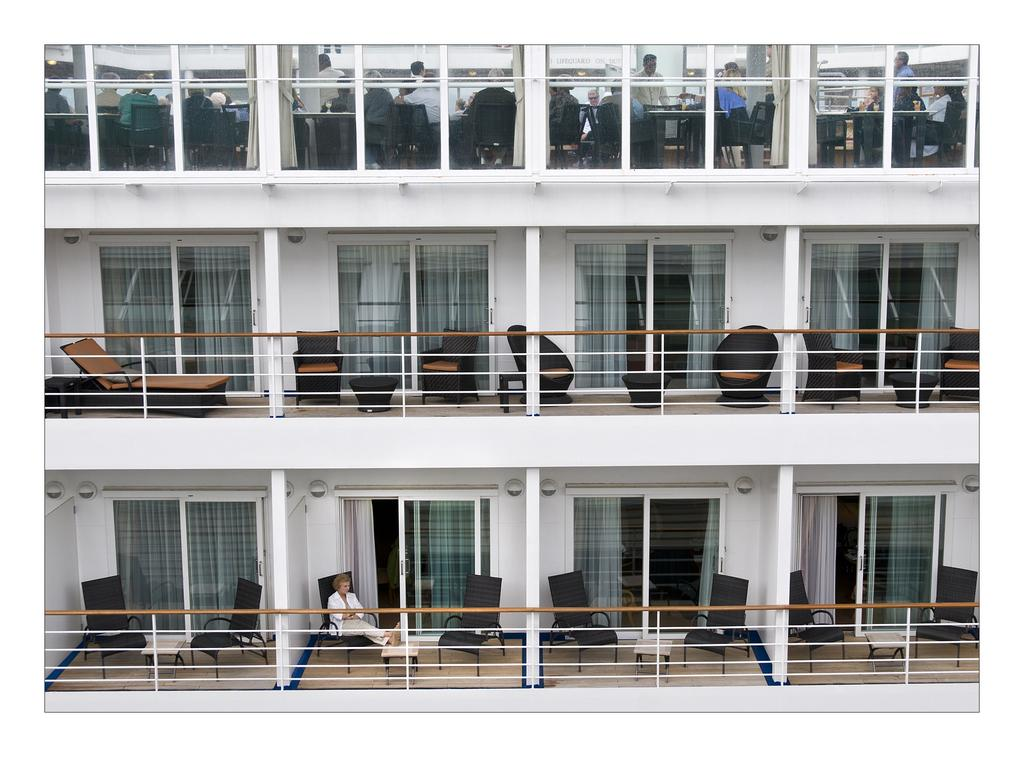What is the color of the building in the image? The building in the image is white. What furniture is present in the building? The building has chairs. What are the people in the image doing? There are people sitting in the chairs. What is the weight of the building in the image? The weight of the building cannot be determined from the image alone. 